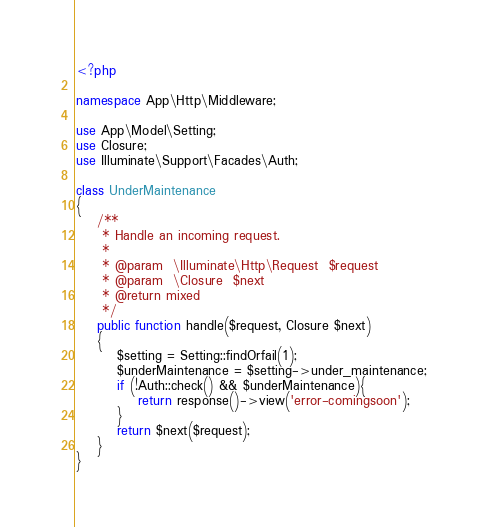<code> <loc_0><loc_0><loc_500><loc_500><_PHP_><?php

namespace App\Http\Middleware;

use App\Model\Setting;
use Closure;
use Illuminate\Support\Facades\Auth;

class UnderMaintenance
{
    /**
     * Handle an incoming request.
     *
     * @param  \Illuminate\Http\Request  $request
     * @param  \Closure  $next
     * @return mixed
     */
    public function handle($request, Closure $next)
    {
        $setting = Setting::findOrfail(1);
        $underMaintenance = $setting->under_maintenance;
        if (!Auth::check() && $underMaintenance){
            return response()->view('error-comingsoon');
        }
        return $next($request);
    }
}
</code> 